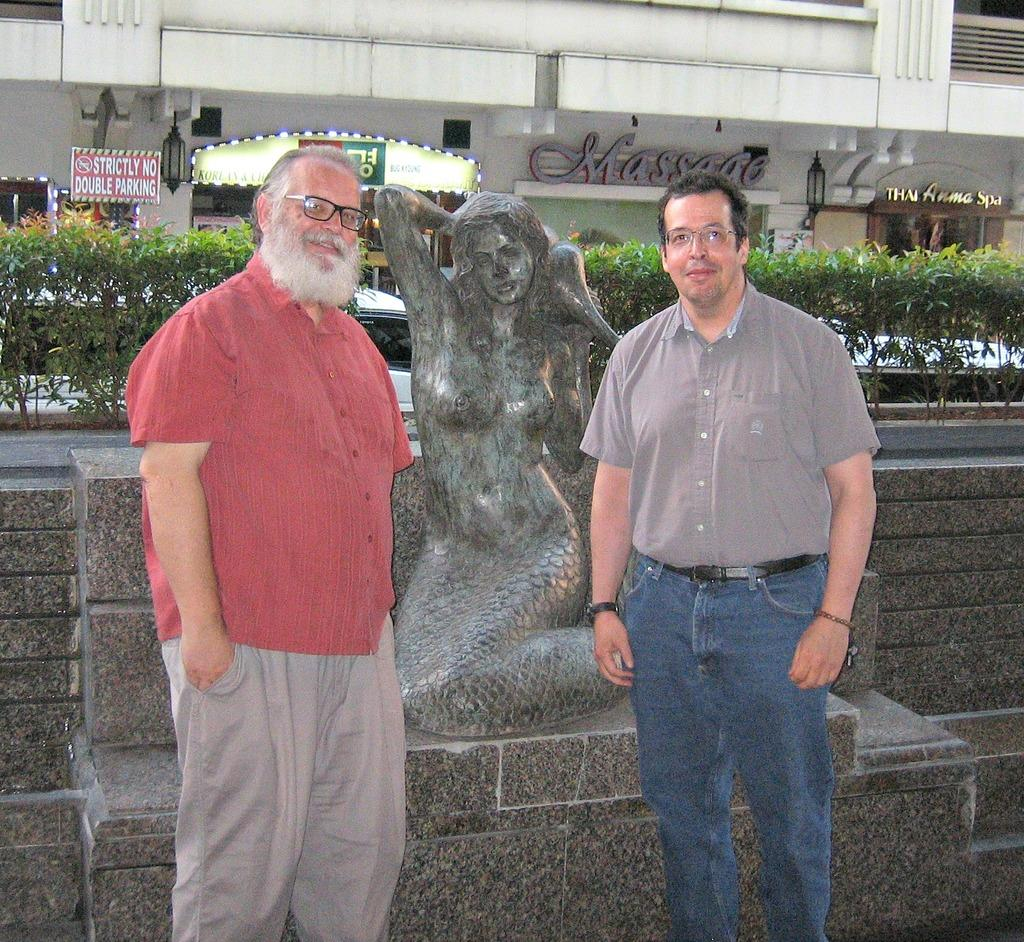How many people are in the image? There are two persons in the image. What are the two persons doing in the image? The two persons are standing beside a scepter and taking pictures. What can be seen in the background of the image? There are trees and buildings visible in the background of the image. What type of chain can be seen connecting the two persons in the image? There is no chain connecting the two persons in the image; they are standing beside a scepter and taking pictures. 